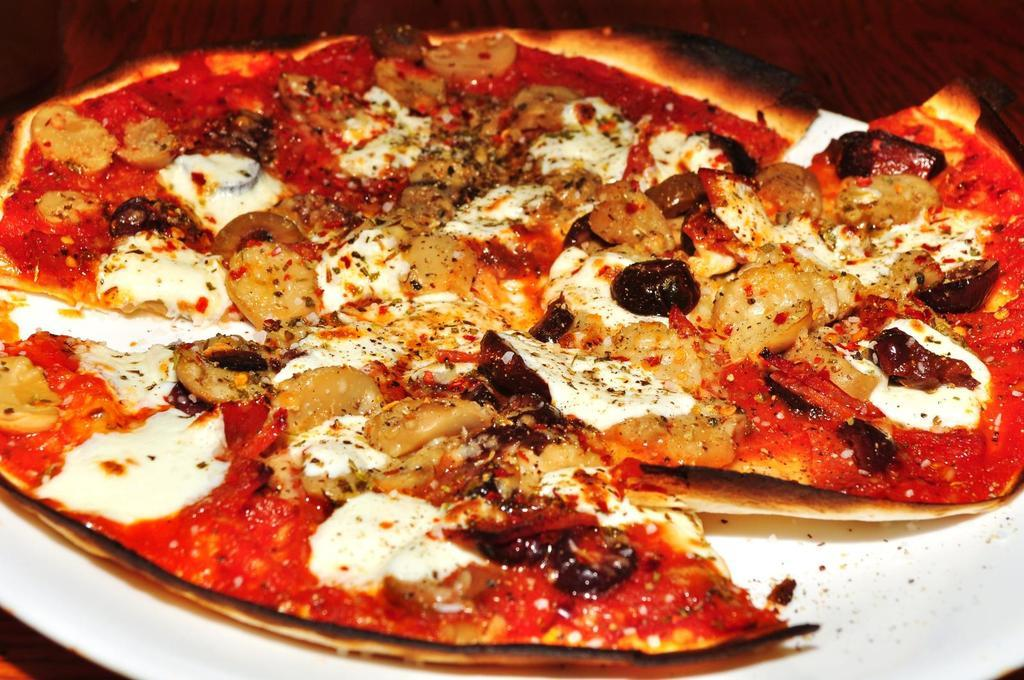What is on the plate at the bottom of the image? There is a pizza on the plate. What type of surface is the plate resting on? The plate is resting on a wooden table in the background of the image. How many ladybugs can be seen crawling on the pizza in the image? There are no ladybugs present on the pizza in the image. 